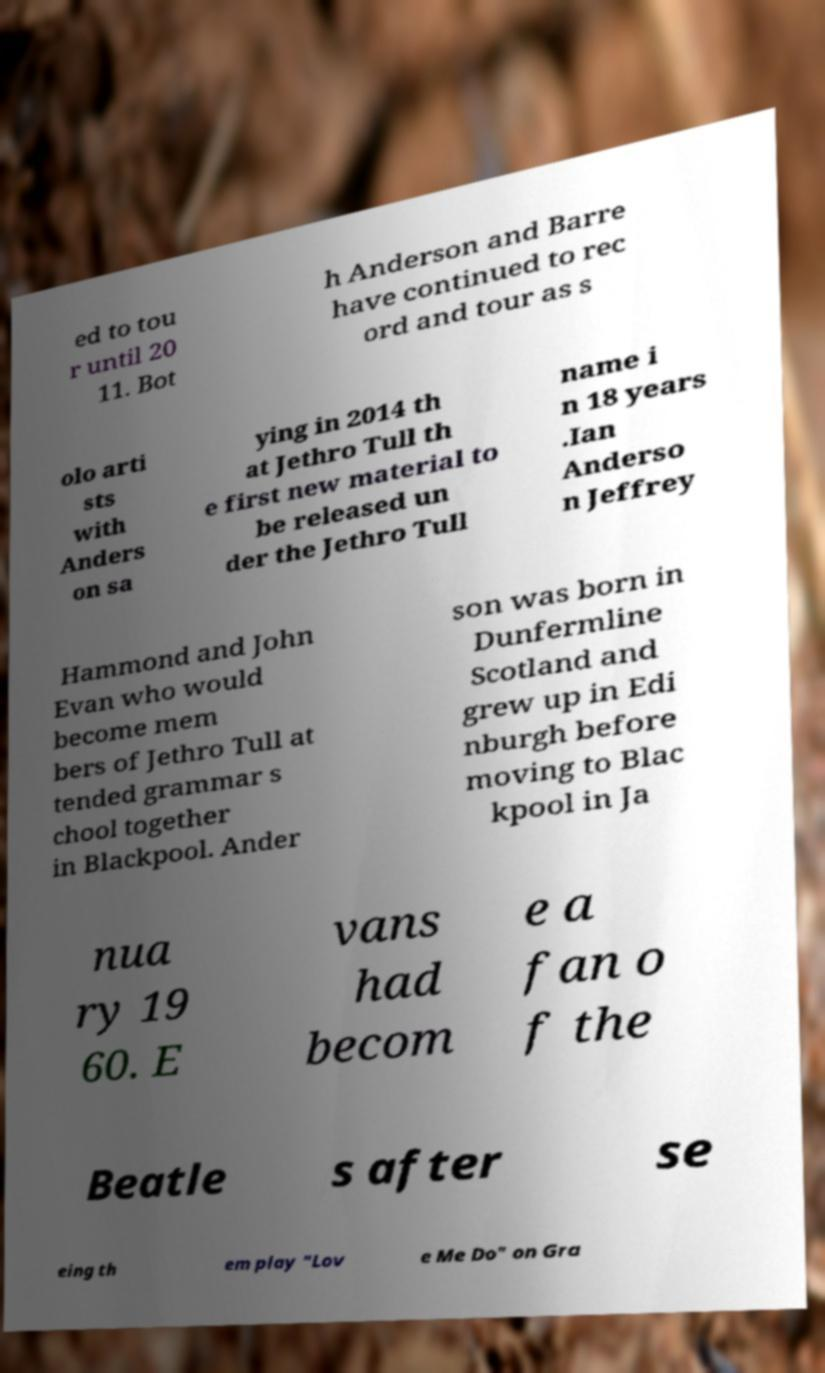Can you accurately transcribe the text from the provided image for me? ed to tou r until 20 11. Bot h Anderson and Barre have continued to rec ord and tour as s olo arti sts with Anders on sa ying in 2014 th at Jethro Tull th e first new material to be released un der the Jethro Tull name i n 18 years .Ian Anderso n Jeffrey Hammond and John Evan who would become mem bers of Jethro Tull at tended grammar s chool together in Blackpool. Ander son was born in Dunfermline Scotland and grew up in Edi nburgh before moving to Blac kpool in Ja nua ry 19 60. E vans had becom e a fan o f the Beatle s after se eing th em play "Lov e Me Do" on Gra 